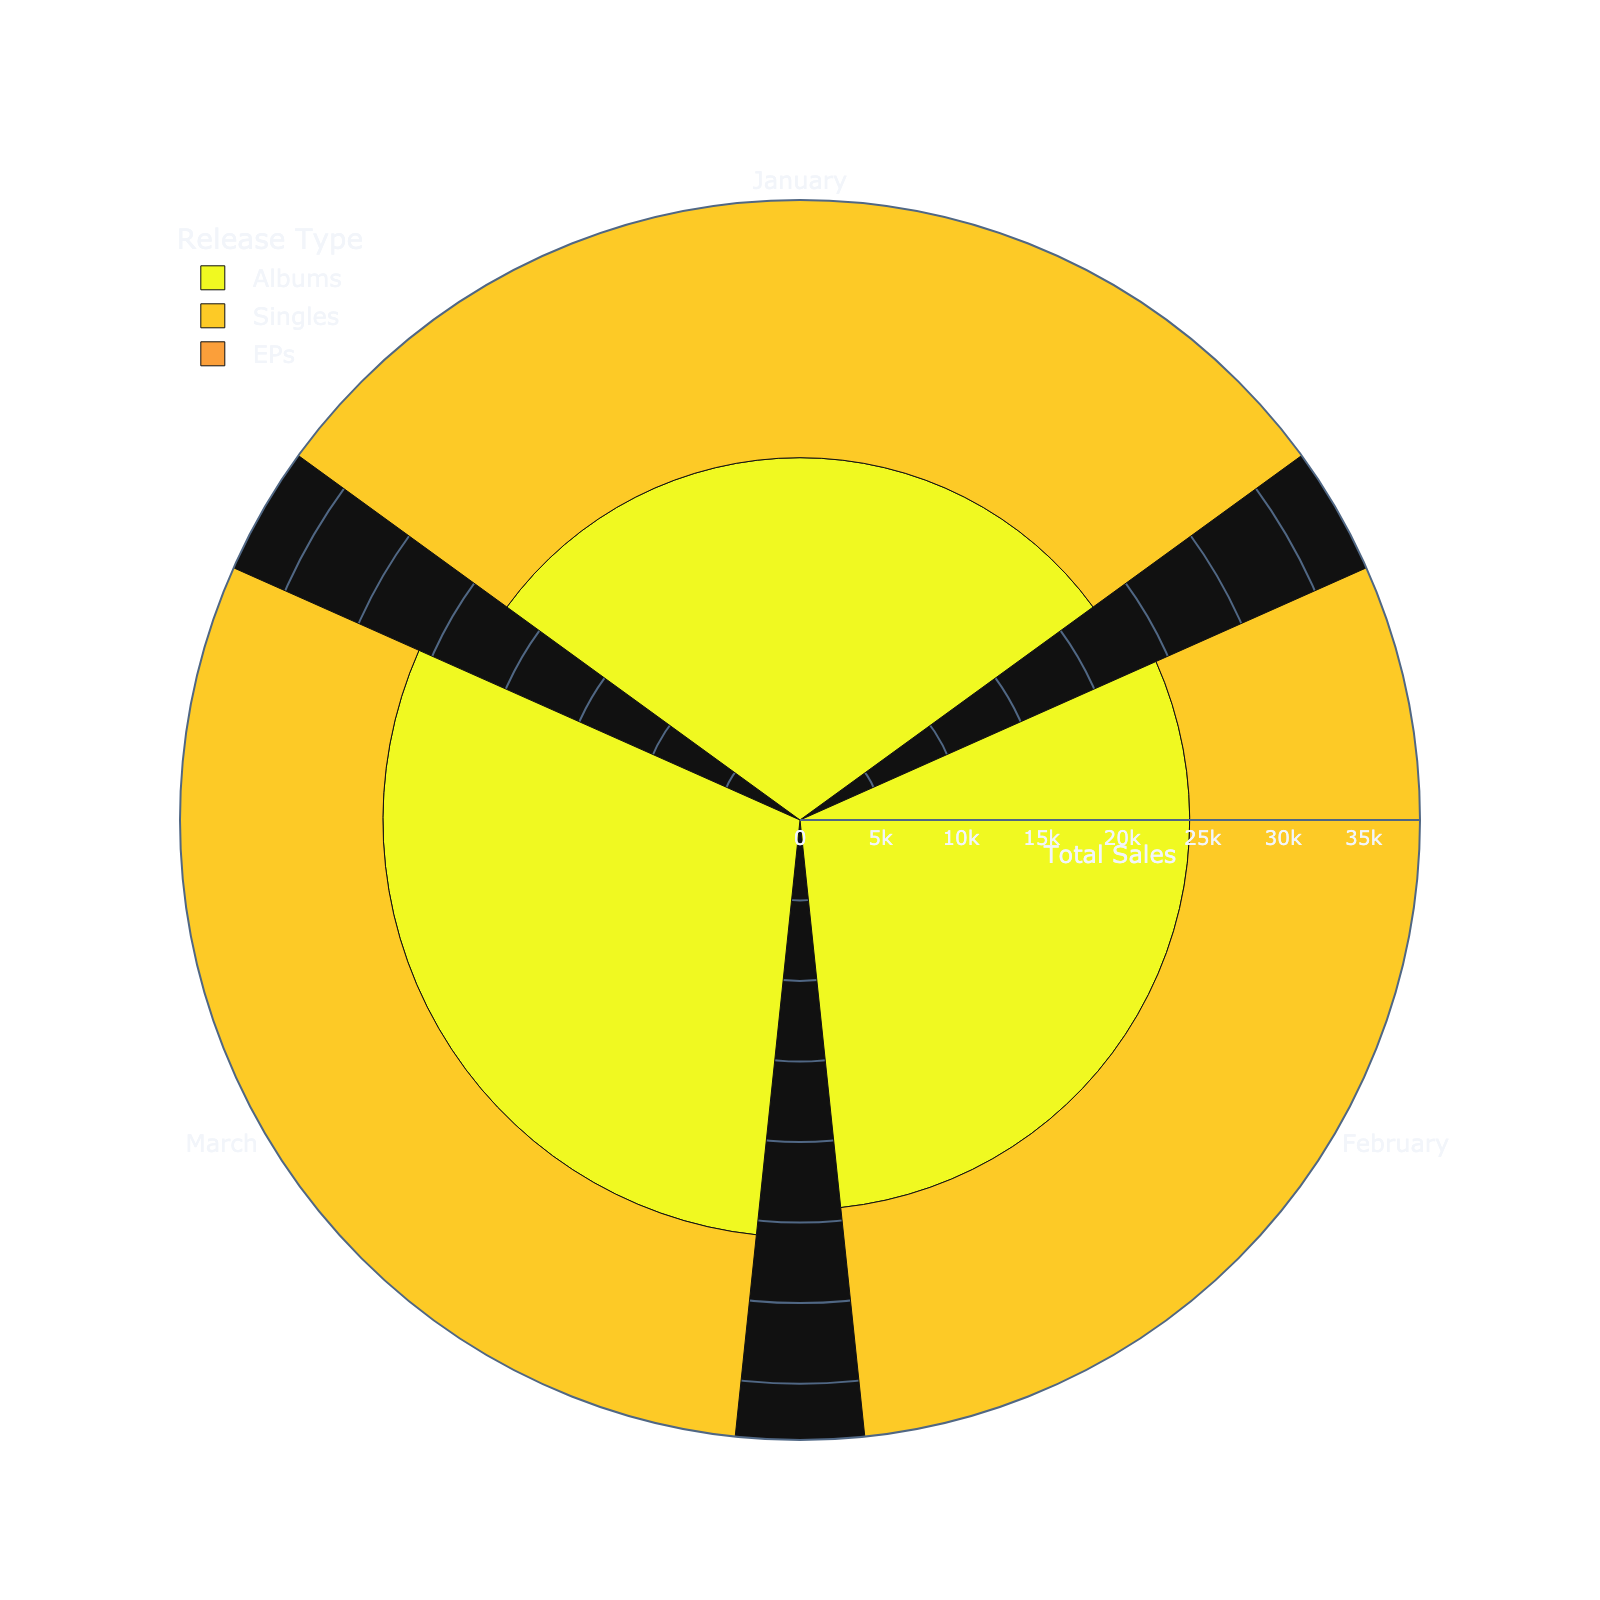Which release type has the highest total combined sales for a single month? Looking at the sections of the rose chart, the largest radius (which indicates the highest total combined sales) appears in the 'Singles' category, specifically in March.
Answer: Singles in March What is the title of the figure? The title is displayed at the top of the figure. It clearly indicates the focus of the chart.
Answer: Monthly Streaming vs. Physical Sales Split by Release Type Which month shows the lowest total sales for EPs? By examining the radial lengths for the EPs in each month, January has the shortest radial length, indicating the lowest sales.
Answer: January Which release type has the most consistent sales across all months? Consistency can be inferred by comparing the radial lengths across months for each release type. 'Albums' have relatively consistent radial lengths.
Answer: Albums How do the total sales for Singles in January compare to the total sales for Singles in February? Compare the radial lengths for Singles in January and February. January has shorter than February indicating lower total sales.
Answer: January has lower sales What's the total combined sales for Singles in March? Add the Streaming and Physical Sales for Singles in March from the data provided (34000 + 1000).
Answer: 35000 Which month has the highest overall total sales for all release types combined? Identify the month with the largest cumulative radial lengths across all release types. March shows the largest outer radial lengths overall.
Answer: March Are February's total sales for Albums higher or lower than January's? Examine the radial lengths for February and January in the Album category. February's radial length is longer than January’s.
Answer: Higher Do EPs have higher total sales in March compared to January? Compare the radial lengths for EPs between March and January. March’s radial length is longer, indicating higher sales.
Answer: Higher What's the combined total sales for Albums across all months? Sum the total sales for Albums from the data provided: (18000+4500) + (20000+4200) + (22000+3900) = 60600
Answer: 60600 